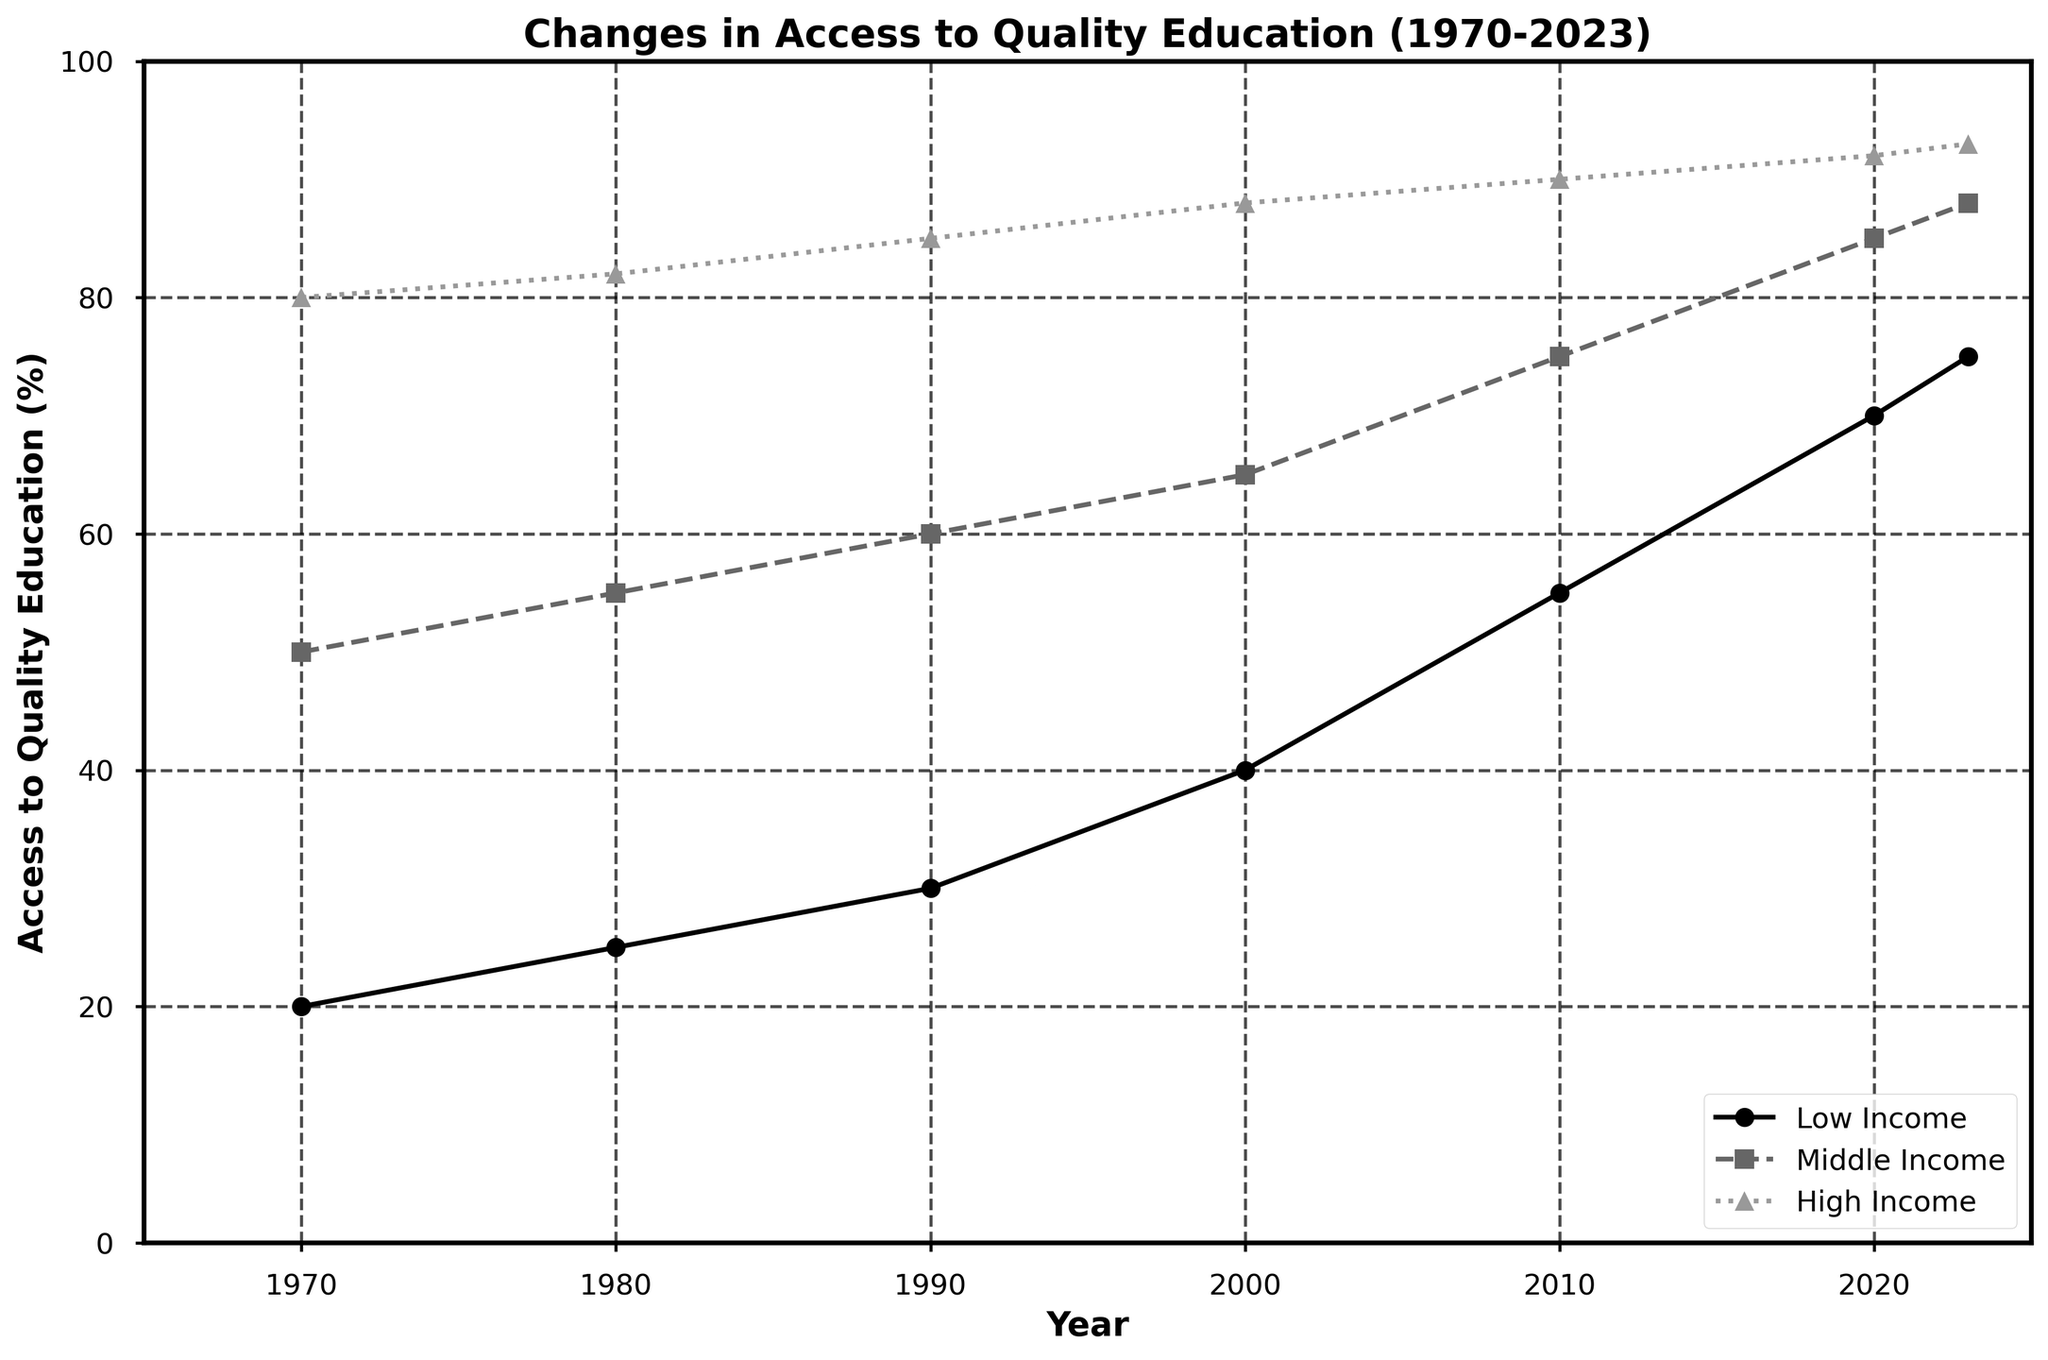What is the title of the figure? The title of the figure is written on top of the plot. The title is "Changes in Access to Quality Education (1970-2023)."
Answer: Changes in Access to Quality Education (1970-2023) Which socio-economic group had the highest access to quality education in 2023? By looking at the access levels in 2023, we see that the "High Income" group has the highest value at 93%.
Answer: High Income How did the access to quality education for Low Income change from 1970 to 2023? In 1970, access for Low Income was 20%, and in 2023, it increased to 75%. The change is calculated as 75% - 20% = 55%.
Answer: Increased by 55% In which decade did Middle Income see the greatest improvement in access to quality education? From the plot, Middle Income access increased from 50% in 1970 to 55% in 1980 (5%), then to 60% in 1990 (5%), and to 65% in 2000 (5%). Between 2000 and 2010, an increase from 65% to 75% is noted (10%). Finally, between 2010 and 2020, an increase from 75% to 85% (10%) and from 2020 to 2023 (3%). The greatest increase occurred between 2000 and 2010, equal to 10%.
Answer: 2000-2010 What is the difference in access to quality education between Low Income and High Income in 1970? The Low Income access in 1970 is 20%, and the High Income access is 80%. The difference is calculated as 80% - 20% = 60%.
Answer: 60% What trend do all socio-economic groups share from 1970 to 2023? Observing the lines for Low Income, Middle Income, and High Income, all of them display an upward trend, indicating that access to quality education has improved for all groups over time.
Answer: Upward trend Which group had the smallest increase in access to quality education between 2010 and 2023? The access to education for Low Income increased from 55% to 75% (20% increase), Middle Income increased from 75% to 88% (13% increase), and High Income increased from 90% to 93% (3% increase). The smallest increase is for the High Income group.
Answer: High Income Compare the rate of change in access to quality education between Low Income and Middle Income groups from 2000 to 2010. For Low Income, access increased from 40% to 55%, a change of 55% - 40% = 15%. For Middle Income, it increased from 65% to 75%, a change of 75% - 65% = 10%. Low Income had a higher rate of change.
Answer: Low Income had a higher rate of change What is the average access to quality education for the Middle Income group across all given years? The access values are 50, 55, 60, 65, 75, 85, and 88. The average is calculated as (50 + 55 + 60 + 65 + 75 + 85 + 88) / 7 = 478 / 7 ≈ 68.29.
Answer: 68.29 During which period did the High Income group experience the slowest growth in access to quality education? The High Income group experienced the smallest growth between 2010 and 2023, where access increased from 90% to 93%, a change of only 3%.
Answer: 2010-2023 